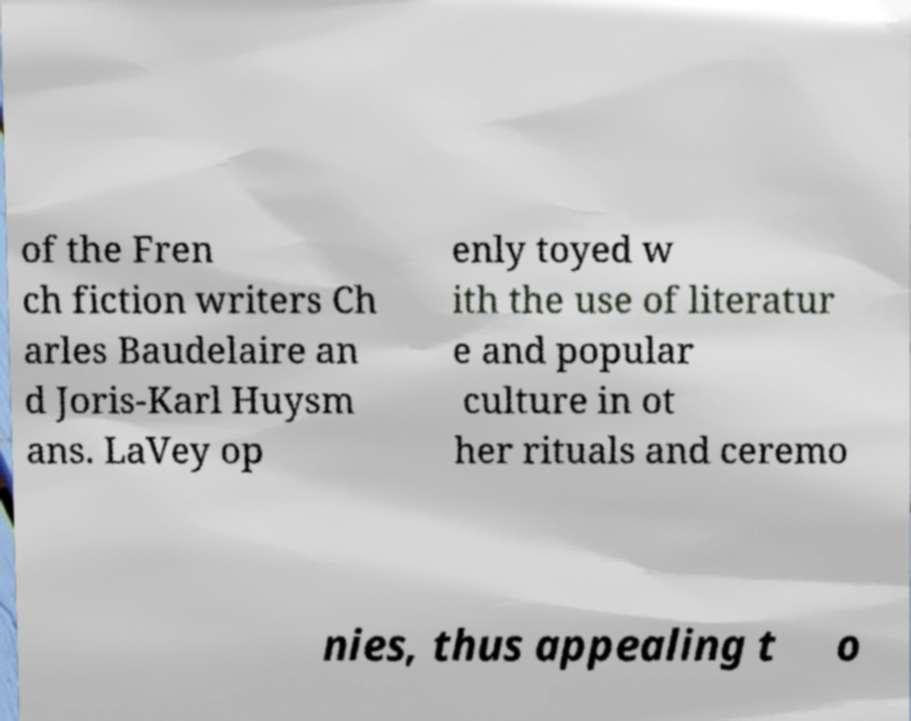Can you accurately transcribe the text from the provided image for me? of the Fren ch fiction writers Ch arles Baudelaire an d Joris-Karl Huysm ans. LaVey op enly toyed w ith the use of literatur e and popular culture in ot her rituals and ceremo nies, thus appealing t o 